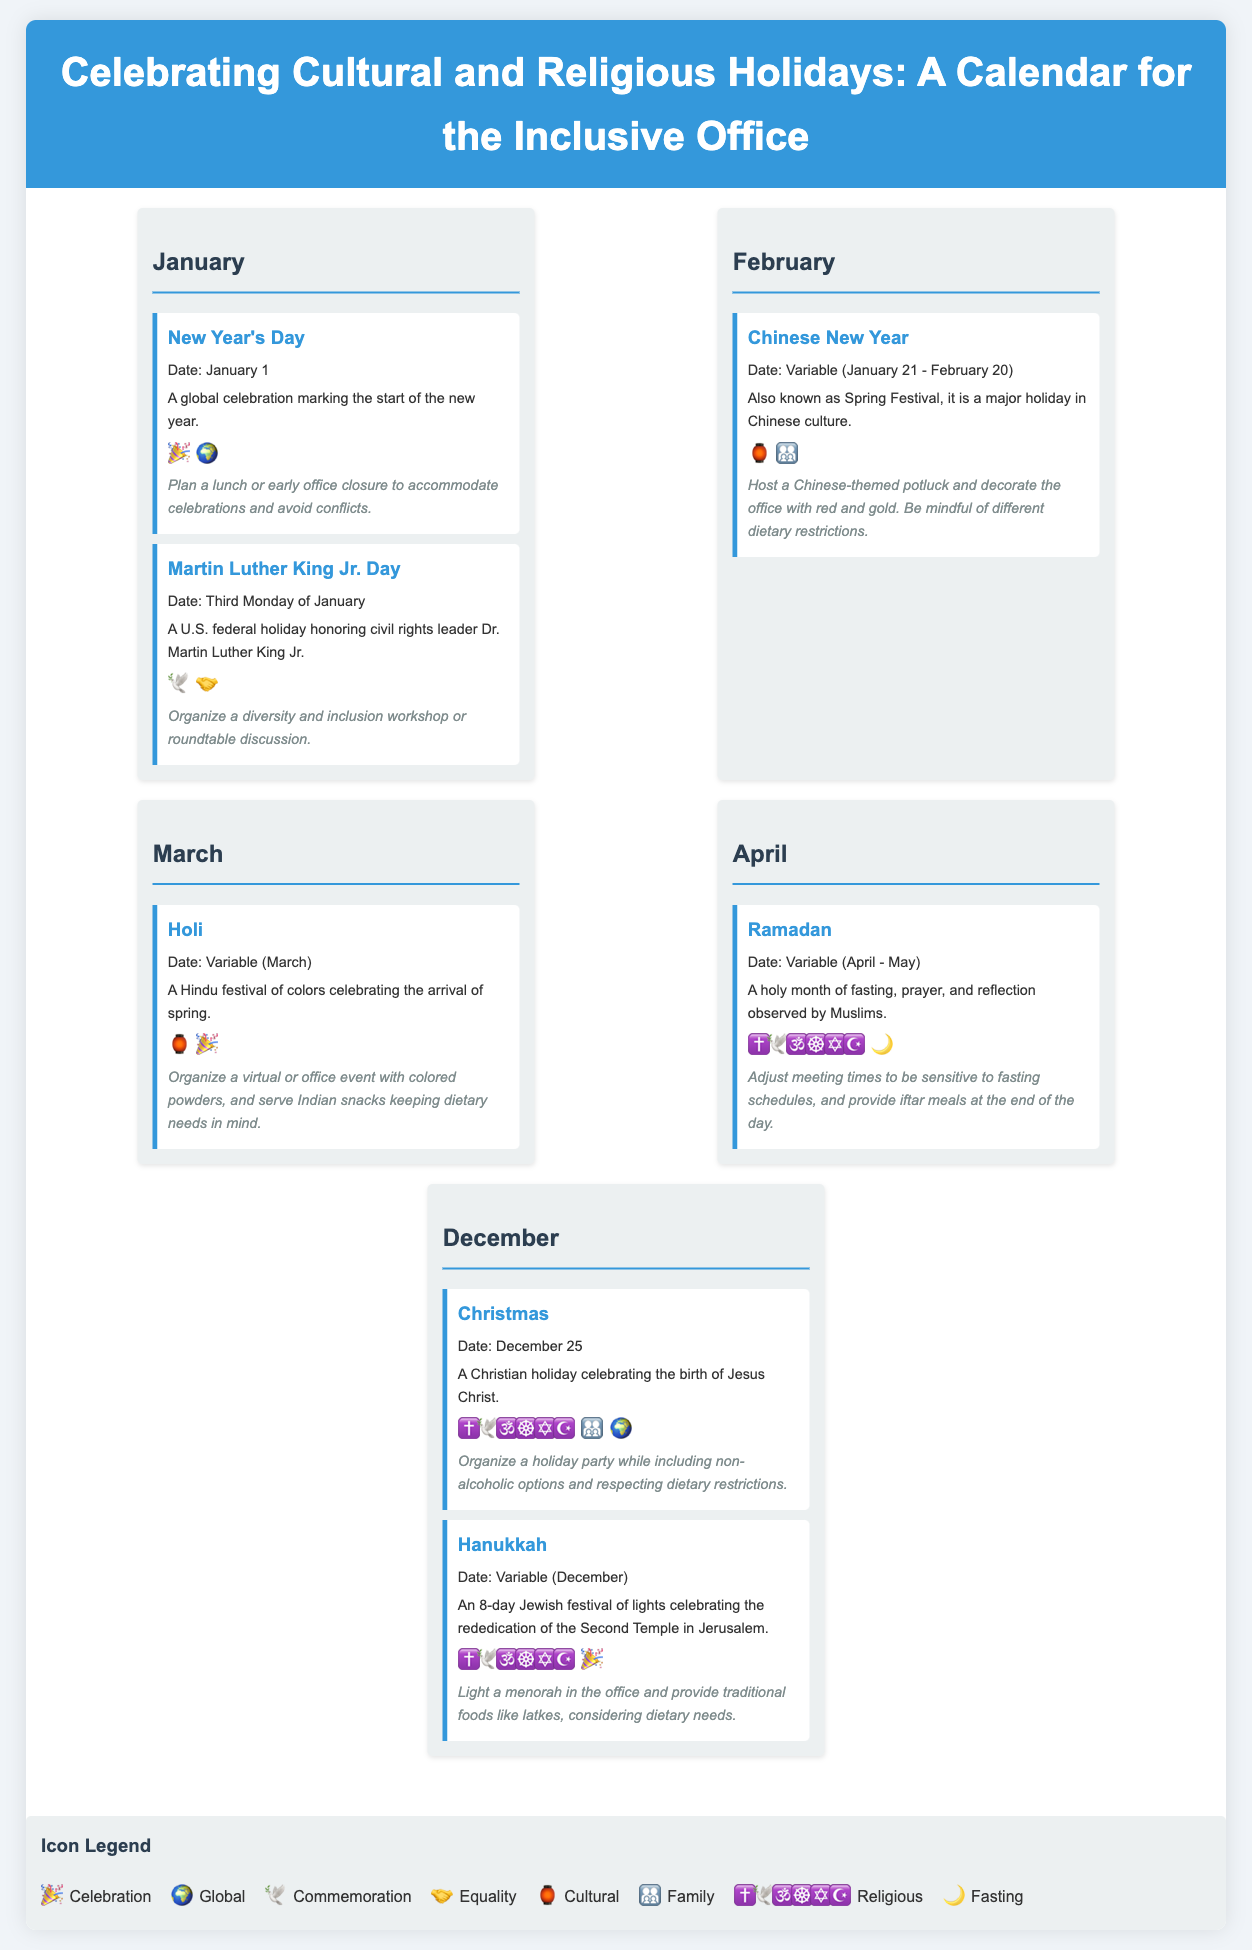What is the date of New Year's Day? The date of New Year's Day is specified within the document as January 1.
Answer: January 1 How many holidays are listed in December? December contains two holidays: Christmas and Hanukkah.
Answer: 2 What is the cultural significance of Holi? Holi is described as a Hindu festival of colors celebrating the arrival of spring.
Answer: Festival of colors What type of event is suggested for Martin Luther King Jr. Day? The document recommends organizing a diversity and inclusion workshop or roundtable discussion.
Answer: Workshop or roundtable discussion What icon represents global celebrations? The icon that represents global celebrations is the globe symbol.
Answer: 🌍 When does Ramadan occur? Ramadan is stated to occur during the variable month of April to May.
Answer: April - May What dietary considerations should be made during the Chinese New Year event? The document advises being mindful of different dietary restrictions during the Chinese-themed potluck for Chinese New Year.
Answer: Dietary restrictions How many cultural icons are included in the legend? The legend includes seven cultural icons that represent different themes.
Answer: 7 What is an appropriate event tip for Christmas? An appropriate event tip for Christmas is to include non-alcoholic options and respect dietary restrictions.
Answer: Non-alcoholic options and dietary restrictions 